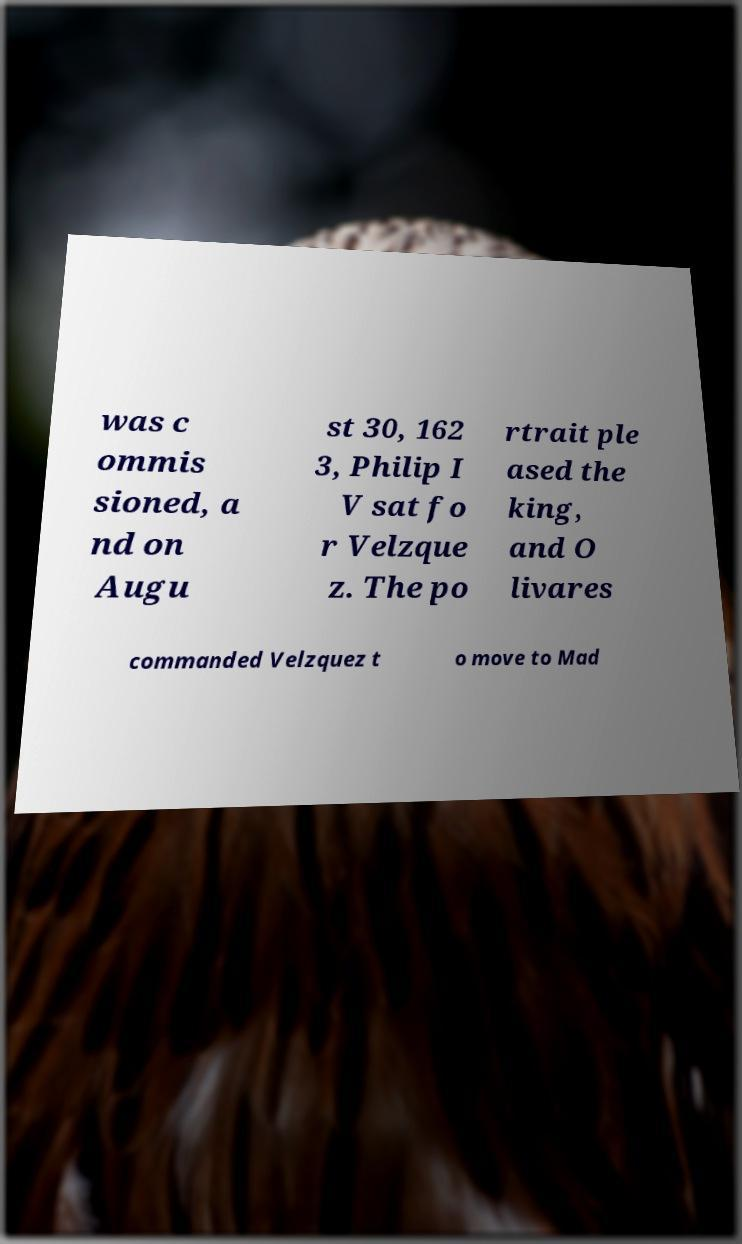For documentation purposes, I need the text within this image transcribed. Could you provide that? was c ommis sioned, a nd on Augu st 30, 162 3, Philip I V sat fo r Velzque z. The po rtrait ple ased the king, and O livares commanded Velzquez t o move to Mad 